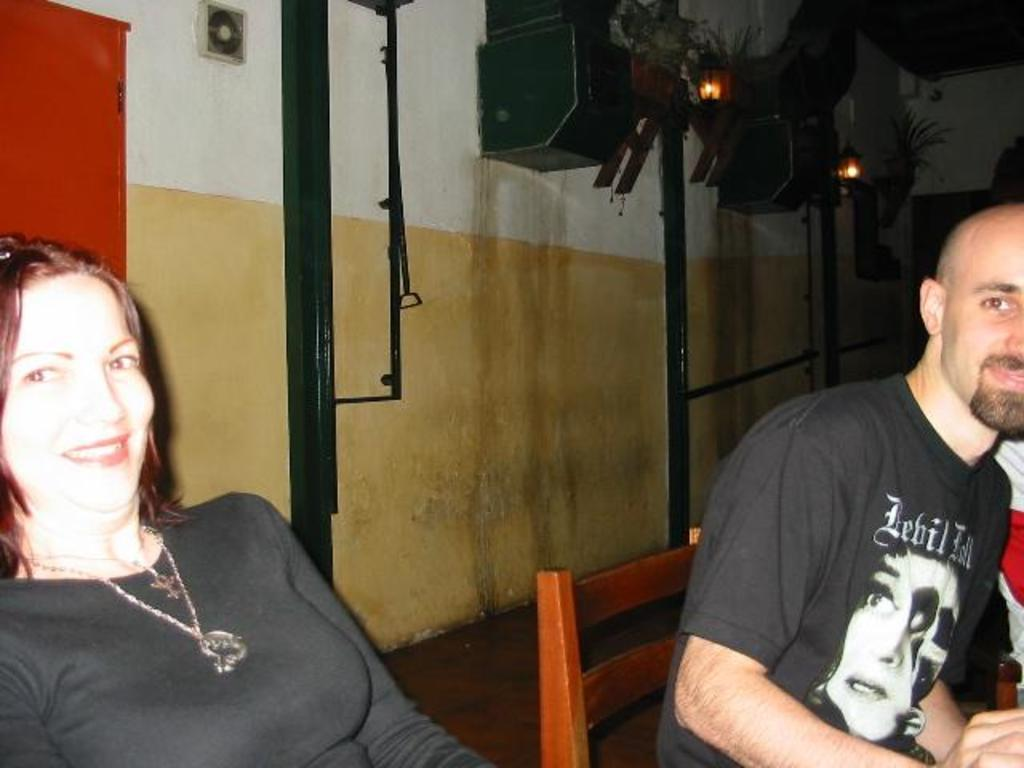How many people are present in the image? There are two people in the image. What can be seen in the background of the image? There is a wall in the background of the image. What is attached to the wall in the image? There is equipment attached to the wall. What is the representative's desire in the image? There is no representative present in the image, so it is not possible to determine their desires. 